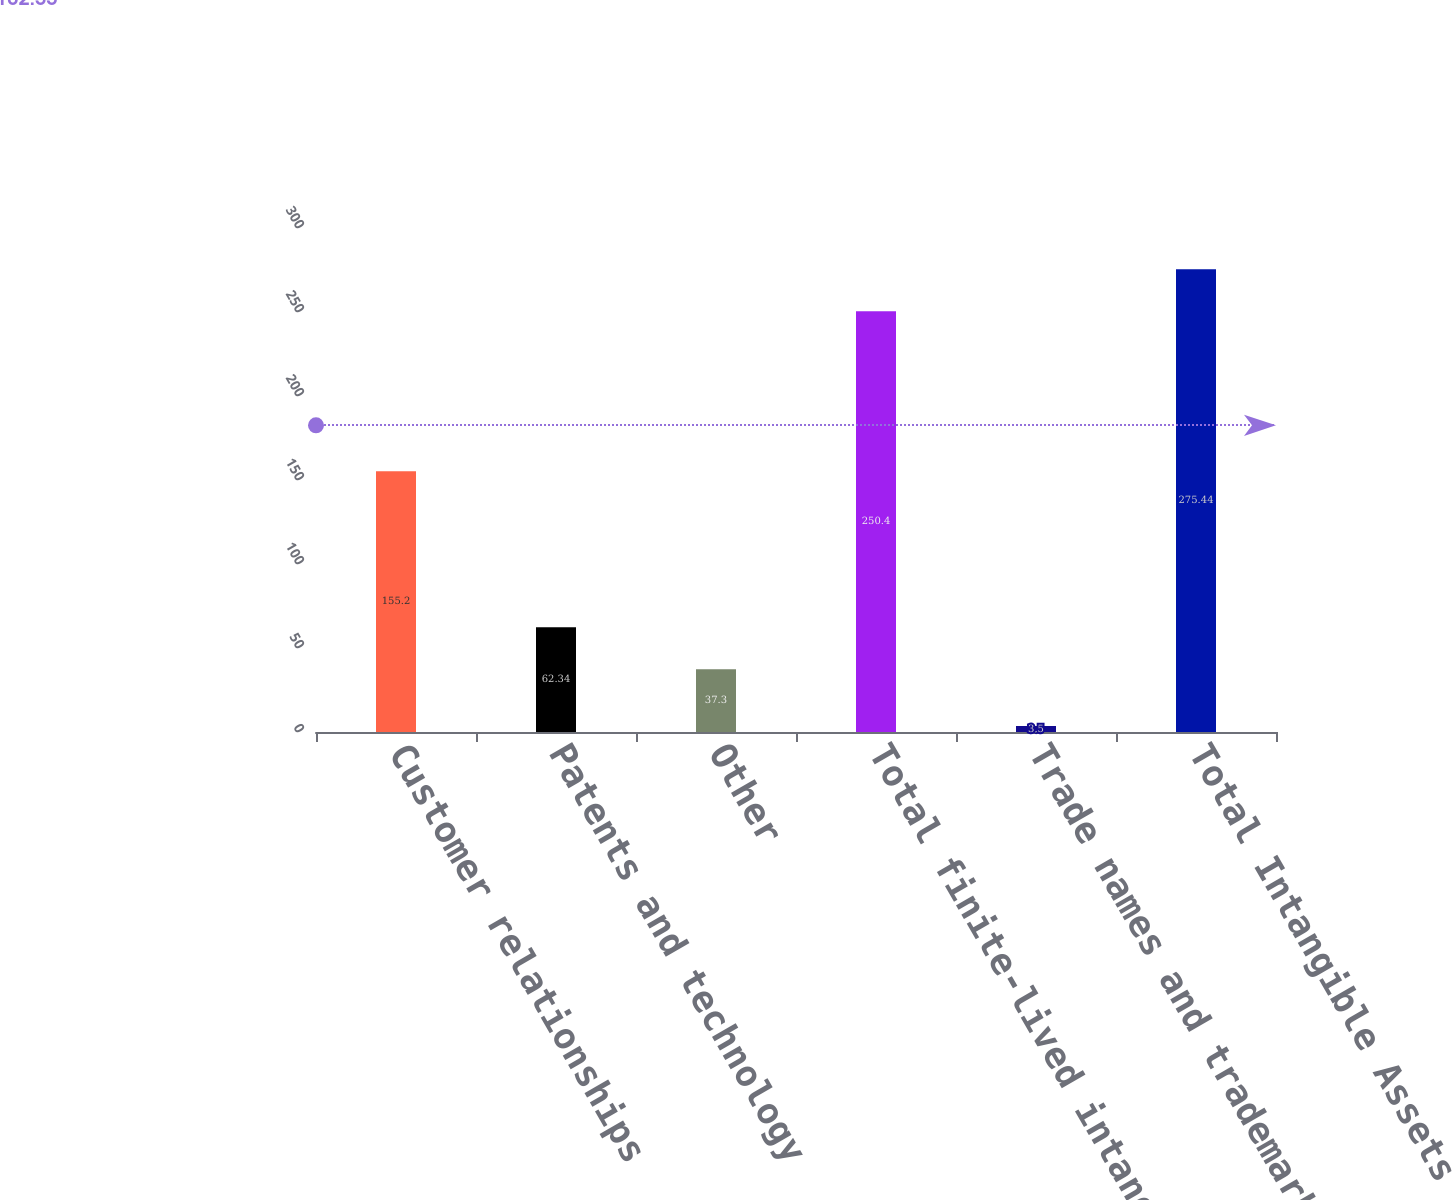<chart> <loc_0><loc_0><loc_500><loc_500><bar_chart><fcel>Customer relationships<fcel>Patents and technology<fcel>Other<fcel>Total finite-lived intangibles<fcel>Trade names and trademarks<fcel>Total Intangible Assets<nl><fcel>155.2<fcel>62.34<fcel>37.3<fcel>250.4<fcel>3.5<fcel>275.44<nl></chart> 